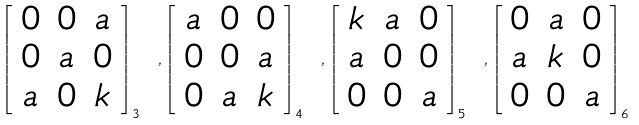Convert formula to latex. <formula><loc_0><loc_0><loc_500><loc_500>\left [ \begin{array} { c c c } 0 & 0 & a \\ 0 & a & 0 \\ a & 0 & k \\ \end{array} \right ] _ { 3 } \ , \left [ \begin{array} { c c c } a & 0 & 0 \\ 0 & 0 & a \\ 0 & a & k \\ \end{array} \right ] _ { 4 } \ , \left [ \begin{array} { c c c } k & a & 0 \\ a & 0 & 0 \\ 0 & 0 & a \\ \end{array} \right ] _ { 5 } \ , \left [ \begin{array} { c c c } 0 & a & 0 \\ a & k & 0 \\ 0 & 0 & a \\ \end{array} \right ] _ { 6 }</formula> 